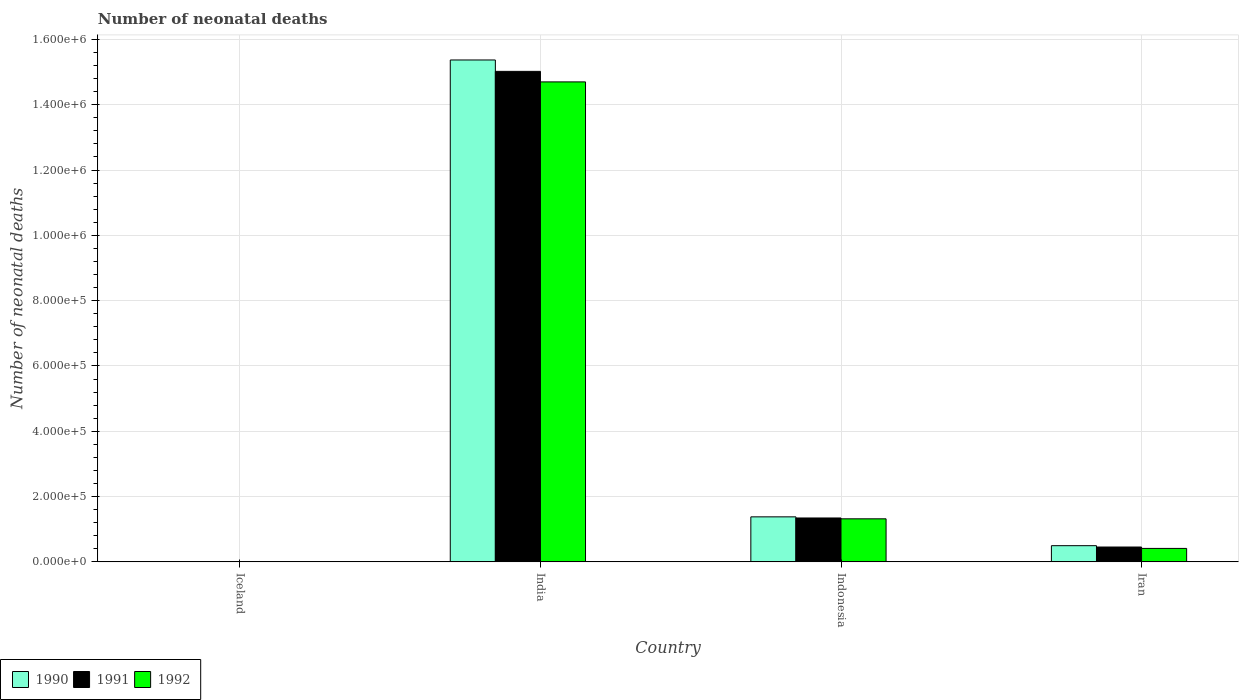How many different coloured bars are there?
Your answer should be very brief. 3. Are the number of bars per tick equal to the number of legend labels?
Provide a succinct answer. Yes. Are the number of bars on each tick of the X-axis equal?
Offer a terse response. Yes. How many bars are there on the 1st tick from the left?
Provide a succinct answer. 3. What is the label of the 4th group of bars from the left?
Your answer should be very brief. Iran. In how many cases, is the number of bars for a given country not equal to the number of legend labels?
Keep it short and to the point. 0. What is the number of neonatal deaths in in 1990 in Iran?
Offer a terse response. 4.96e+04. Across all countries, what is the maximum number of neonatal deaths in in 1991?
Provide a short and direct response. 1.50e+06. Across all countries, what is the minimum number of neonatal deaths in in 1991?
Make the answer very short. 15. What is the total number of neonatal deaths in in 1992 in the graph?
Make the answer very short. 1.64e+06. What is the difference between the number of neonatal deaths in in 1992 in Indonesia and that in Iran?
Your response must be concise. 9.06e+04. What is the difference between the number of neonatal deaths in in 1992 in Indonesia and the number of neonatal deaths in in 1990 in India?
Your answer should be very brief. -1.41e+06. What is the average number of neonatal deaths in in 1992 per country?
Offer a terse response. 4.11e+05. What is the difference between the number of neonatal deaths in of/in 1992 and number of neonatal deaths in of/in 1990 in Iceland?
Your answer should be compact. -1. What is the ratio of the number of neonatal deaths in in 1990 in Iceland to that in Iran?
Ensure brevity in your answer.  0. Is the number of neonatal deaths in in 1991 in Iceland less than that in Iran?
Your answer should be very brief. Yes. What is the difference between the highest and the second highest number of neonatal deaths in in 1991?
Provide a succinct answer. -8.89e+04. What is the difference between the highest and the lowest number of neonatal deaths in in 1992?
Your response must be concise. 1.47e+06. Is the sum of the number of neonatal deaths in in 1990 in India and Iran greater than the maximum number of neonatal deaths in in 1992 across all countries?
Ensure brevity in your answer.  Yes. What does the 2nd bar from the left in Iceland represents?
Give a very brief answer. 1991. What does the 3rd bar from the right in Indonesia represents?
Provide a succinct answer. 1990. Are all the bars in the graph horizontal?
Offer a very short reply. No. How many countries are there in the graph?
Provide a succinct answer. 4. What is the difference between two consecutive major ticks on the Y-axis?
Your answer should be compact. 2.00e+05. Where does the legend appear in the graph?
Your answer should be compact. Bottom left. How many legend labels are there?
Offer a very short reply. 3. What is the title of the graph?
Keep it short and to the point. Number of neonatal deaths. Does "1999" appear as one of the legend labels in the graph?
Your response must be concise. No. What is the label or title of the Y-axis?
Your answer should be very brief. Number of neonatal deaths. What is the Number of neonatal deaths of 1990 in Iceland?
Provide a succinct answer. 15. What is the Number of neonatal deaths of 1992 in Iceland?
Your response must be concise. 14. What is the Number of neonatal deaths of 1990 in India?
Your answer should be very brief. 1.54e+06. What is the Number of neonatal deaths in 1991 in India?
Provide a succinct answer. 1.50e+06. What is the Number of neonatal deaths of 1992 in India?
Offer a terse response. 1.47e+06. What is the Number of neonatal deaths of 1990 in Indonesia?
Offer a very short reply. 1.38e+05. What is the Number of neonatal deaths in 1991 in Indonesia?
Make the answer very short. 1.34e+05. What is the Number of neonatal deaths in 1992 in Indonesia?
Offer a terse response. 1.32e+05. What is the Number of neonatal deaths of 1990 in Iran?
Provide a short and direct response. 4.96e+04. What is the Number of neonatal deaths in 1991 in Iran?
Your response must be concise. 4.55e+04. What is the Number of neonatal deaths in 1992 in Iran?
Your answer should be compact. 4.12e+04. Across all countries, what is the maximum Number of neonatal deaths of 1990?
Offer a very short reply. 1.54e+06. Across all countries, what is the maximum Number of neonatal deaths in 1991?
Ensure brevity in your answer.  1.50e+06. Across all countries, what is the maximum Number of neonatal deaths of 1992?
Your answer should be compact. 1.47e+06. Across all countries, what is the minimum Number of neonatal deaths of 1991?
Your answer should be very brief. 15. Across all countries, what is the minimum Number of neonatal deaths of 1992?
Provide a succinct answer. 14. What is the total Number of neonatal deaths of 1990 in the graph?
Offer a terse response. 1.72e+06. What is the total Number of neonatal deaths of 1991 in the graph?
Your answer should be very brief. 1.68e+06. What is the total Number of neonatal deaths of 1992 in the graph?
Keep it short and to the point. 1.64e+06. What is the difference between the Number of neonatal deaths in 1990 in Iceland and that in India?
Your answer should be very brief. -1.54e+06. What is the difference between the Number of neonatal deaths in 1991 in Iceland and that in India?
Provide a succinct answer. -1.50e+06. What is the difference between the Number of neonatal deaths in 1992 in Iceland and that in India?
Make the answer very short. -1.47e+06. What is the difference between the Number of neonatal deaths in 1990 in Iceland and that in Indonesia?
Ensure brevity in your answer.  -1.38e+05. What is the difference between the Number of neonatal deaths in 1991 in Iceland and that in Indonesia?
Keep it short and to the point. -1.34e+05. What is the difference between the Number of neonatal deaths in 1992 in Iceland and that in Indonesia?
Keep it short and to the point. -1.32e+05. What is the difference between the Number of neonatal deaths in 1990 in Iceland and that in Iran?
Provide a short and direct response. -4.96e+04. What is the difference between the Number of neonatal deaths of 1991 in Iceland and that in Iran?
Give a very brief answer. -4.55e+04. What is the difference between the Number of neonatal deaths in 1992 in Iceland and that in Iran?
Your answer should be very brief. -4.12e+04. What is the difference between the Number of neonatal deaths in 1990 in India and that in Indonesia?
Make the answer very short. 1.40e+06. What is the difference between the Number of neonatal deaths in 1991 in India and that in Indonesia?
Your answer should be very brief. 1.37e+06. What is the difference between the Number of neonatal deaths in 1992 in India and that in Indonesia?
Offer a terse response. 1.34e+06. What is the difference between the Number of neonatal deaths of 1990 in India and that in Iran?
Your answer should be compact. 1.49e+06. What is the difference between the Number of neonatal deaths of 1991 in India and that in Iran?
Keep it short and to the point. 1.46e+06. What is the difference between the Number of neonatal deaths of 1992 in India and that in Iran?
Provide a succinct answer. 1.43e+06. What is the difference between the Number of neonatal deaths in 1990 in Indonesia and that in Iran?
Ensure brevity in your answer.  8.83e+04. What is the difference between the Number of neonatal deaths of 1991 in Indonesia and that in Iran?
Keep it short and to the point. 8.89e+04. What is the difference between the Number of neonatal deaths of 1992 in Indonesia and that in Iran?
Provide a succinct answer. 9.06e+04. What is the difference between the Number of neonatal deaths of 1990 in Iceland and the Number of neonatal deaths of 1991 in India?
Offer a very short reply. -1.50e+06. What is the difference between the Number of neonatal deaths in 1990 in Iceland and the Number of neonatal deaths in 1992 in India?
Give a very brief answer. -1.47e+06. What is the difference between the Number of neonatal deaths in 1991 in Iceland and the Number of neonatal deaths in 1992 in India?
Keep it short and to the point. -1.47e+06. What is the difference between the Number of neonatal deaths of 1990 in Iceland and the Number of neonatal deaths of 1991 in Indonesia?
Your response must be concise. -1.34e+05. What is the difference between the Number of neonatal deaths of 1990 in Iceland and the Number of neonatal deaths of 1992 in Indonesia?
Your answer should be compact. -1.32e+05. What is the difference between the Number of neonatal deaths in 1991 in Iceland and the Number of neonatal deaths in 1992 in Indonesia?
Ensure brevity in your answer.  -1.32e+05. What is the difference between the Number of neonatal deaths in 1990 in Iceland and the Number of neonatal deaths in 1991 in Iran?
Offer a very short reply. -4.55e+04. What is the difference between the Number of neonatal deaths of 1990 in Iceland and the Number of neonatal deaths of 1992 in Iran?
Offer a very short reply. -4.12e+04. What is the difference between the Number of neonatal deaths of 1991 in Iceland and the Number of neonatal deaths of 1992 in Iran?
Offer a very short reply. -4.12e+04. What is the difference between the Number of neonatal deaths in 1990 in India and the Number of neonatal deaths in 1991 in Indonesia?
Your answer should be compact. 1.40e+06. What is the difference between the Number of neonatal deaths of 1990 in India and the Number of neonatal deaths of 1992 in Indonesia?
Your answer should be compact. 1.41e+06. What is the difference between the Number of neonatal deaths of 1991 in India and the Number of neonatal deaths of 1992 in Indonesia?
Provide a succinct answer. 1.37e+06. What is the difference between the Number of neonatal deaths of 1990 in India and the Number of neonatal deaths of 1991 in Iran?
Provide a succinct answer. 1.49e+06. What is the difference between the Number of neonatal deaths in 1990 in India and the Number of neonatal deaths in 1992 in Iran?
Keep it short and to the point. 1.50e+06. What is the difference between the Number of neonatal deaths of 1991 in India and the Number of neonatal deaths of 1992 in Iran?
Provide a short and direct response. 1.46e+06. What is the difference between the Number of neonatal deaths in 1990 in Indonesia and the Number of neonatal deaths in 1991 in Iran?
Your answer should be very brief. 9.24e+04. What is the difference between the Number of neonatal deaths of 1990 in Indonesia and the Number of neonatal deaths of 1992 in Iran?
Keep it short and to the point. 9.67e+04. What is the difference between the Number of neonatal deaths in 1991 in Indonesia and the Number of neonatal deaths in 1992 in Iran?
Offer a very short reply. 9.32e+04. What is the average Number of neonatal deaths of 1990 per country?
Give a very brief answer. 4.31e+05. What is the average Number of neonatal deaths in 1991 per country?
Give a very brief answer. 4.21e+05. What is the average Number of neonatal deaths in 1992 per country?
Your answer should be compact. 4.11e+05. What is the difference between the Number of neonatal deaths of 1990 and Number of neonatal deaths of 1991 in Iceland?
Provide a short and direct response. 0. What is the difference between the Number of neonatal deaths in 1990 and Number of neonatal deaths in 1992 in Iceland?
Make the answer very short. 1. What is the difference between the Number of neonatal deaths of 1991 and Number of neonatal deaths of 1992 in Iceland?
Your response must be concise. 1. What is the difference between the Number of neonatal deaths in 1990 and Number of neonatal deaths in 1991 in India?
Your response must be concise. 3.49e+04. What is the difference between the Number of neonatal deaths in 1990 and Number of neonatal deaths in 1992 in India?
Offer a terse response. 6.71e+04. What is the difference between the Number of neonatal deaths of 1991 and Number of neonatal deaths of 1992 in India?
Offer a terse response. 3.22e+04. What is the difference between the Number of neonatal deaths in 1990 and Number of neonatal deaths in 1991 in Indonesia?
Your answer should be compact. 3471. What is the difference between the Number of neonatal deaths in 1990 and Number of neonatal deaths in 1992 in Indonesia?
Offer a terse response. 6057. What is the difference between the Number of neonatal deaths in 1991 and Number of neonatal deaths in 1992 in Indonesia?
Your answer should be very brief. 2586. What is the difference between the Number of neonatal deaths of 1990 and Number of neonatal deaths of 1991 in Iran?
Ensure brevity in your answer.  4129. What is the difference between the Number of neonatal deaths of 1990 and Number of neonatal deaths of 1992 in Iran?
Provide a succinct answer. 8392. What is the difference between the Number of neonatal deaths of 1991 and Number of neonatal deaths of 1992 in Iran?
Your answer should be compact. 4263. What is the ratio of the Number of neonatal deaths in 1990 in Iceland to that in India?
Ensure brevity in your answer.  0. What is the ratio of the Number of neonatal deaths of 1992 in Iceland to that in India?
Your answer should be compact. 0. What is the ratio of the Number of neonatal deaths of 1990 in Iceland to that in Indonesia?
Offer a terse response. 0. What is the ratio of the Number of neonatal deaths of 1991 in Iceland to that in Indonesia?
Offer a terse response. 0. What is the ratio of the Number of neonatal deaths in 1992 in Iceland to that in Indonesia?
Your response must be concise. 0. What is the ratio of the Number of neonatal deaths of 1990 in Iceland to that in Iran?
Your answer should be compact. 0. What is the ratio of the Number of neonatal deaths of 1992 in Iceland to that in Iran?
Provide a succinct answer. 0. What is the ratio of the Number of neonatal deaths of 1990 in India to that in Indonesia?
Your answer should be compact. 11.15. What is the ratio of the Number of neonatal deaths in 1991 in India to that in Indonesia?
Ensure brevity in your answer.  11.18. What is the ratio of the Number of neonatal deaths of 1992 in India to that in Indonesia?
Your answer should be compact. 11.15. What is the ratio of the Number of neonatal deaths in 1990 in India to that in Iran?
Make the answer very short. 30.98. What is the ratio of the Number of neonatal deaths of 1991 in India to that in Iran?
Provide a short and direct response. 33.03. What is the ratio of the Number of neonatal deaths in 1992 in India to that in Iran?
Provide a short and direct response. 35.66. What is the ratio of the Number of neonatal deaths of 1990 in Indonesia to that in Iran?
Make the answer very short. 2.78. What is the ratio of the Number of neonatal deaths of 1991 in Indonesia to that in Iran?
Keep it short and to the point. 2.96. What is the ratio of the Number of neonatal deaths in 1992 in Indonesia to that in Iran?
Offer a terse response. 3.2. What is the difference between the highest and the second highest Number of neonatal deaths of 1990?
Give a very brief answer. 1.40e+06. What is the difference between the highest and the second highest Number of neonatal deaths of 1991?
Your response must be concise. 1.37e+06. What is the difference between the highest and the second highest Number of neonatal deaths in 1992?
Offer a terse response. 1.34e+06. What is the difference between the highest and the lowest Number of neonatal deaths of 1990?
Keep it short and to the point. 1.54e+06. What is the difference between the highest and the lowest Number of neonatal deaths in 1991?
Provide a succinct answer. 1.50e+06. What is the difference between the highest and the lowest Number of neonatal deaths of 1992?
Give a very brief answer. 1.47e+06. 